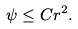Convert formula to latex. <formula><loc_0><loc_0><loc_500><loc_500>\psi \leq C r ^ { 2 } .</formula> 